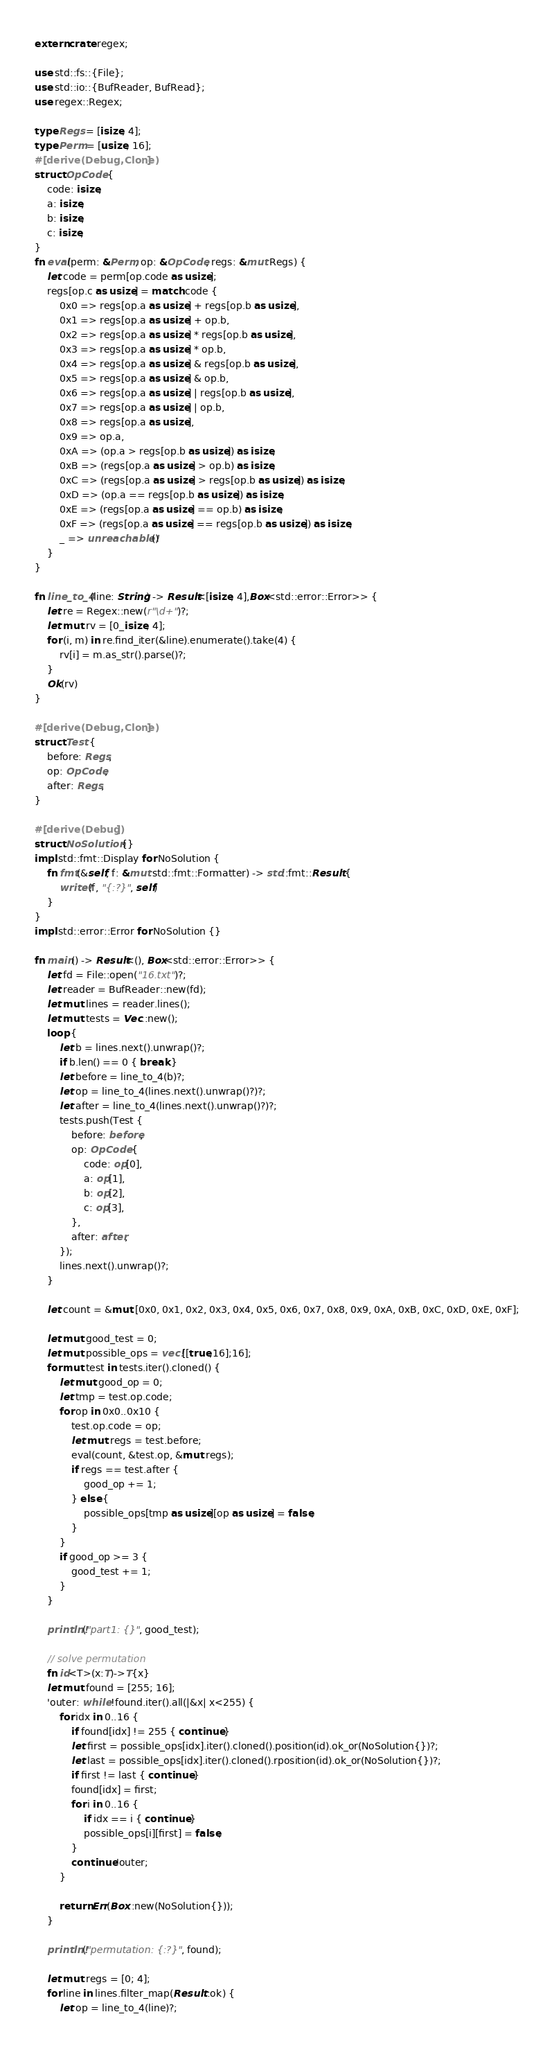Convert code to text. <code><loc_0><loc_0><loc_500><loc_500><_Rust_>extern crate regex;

use std::fs::{File};
use std::io::{BufReader, BufRead};
use regex::Regex;

type Regs = [isize; 4];
type Perm = [usize; 16];
#[derive(Debug,Clone)]
struct OpCode {
    code: isize,
    a: isize,
    b: isize,
    c: isize,
}
fn eval(perm: &Perm, op: &OpCode, regs: &mut Regs) {
    let code = perm[op.code as usize];
    regs[op.c as usize] = match code {
        0x0 => regs[op.a as usize] + regs[op.b as usize],
        0x1 => regs[op.a as usize] + op.b,
        0x2 => regs[op.a as usize] * regs[op.b as usize],
        0x3 => regs[op.a as usize] * op.b,
        0x4 => regs[op.a as usize] & regs[op.b as usize],
        0x5 => regs[op.a as usize] & op.b,
        0x6 => regs[op.a as usize] | regs[op.b as usize],
        0x7 => regs[op.a as usize] | op.b,
        0x8 => regs[op.a as usize],
        0x9 => op.a,
        0xA => (op.a > regs[op.b as usize]) as isize,
        0xB => (regs[op.a as usize] > op.b) as isize,
        0xC => (regs[op.a as usize] > regs[op.b as usize]) as isize,
        0xD => (op.a == regs[op.b as usize]) as isize,
        0xE => (regs[op.a as usize] == op.b) as isize,
        0xF => (regs[op.a as usize] == regs[op.b as usize]) as isize,
        _ => unreachable!()
    }
}

fn line_to_4(line: String) -> Result<[isize; 4],Box<std::error::Error>> {
    let re = Regex::new(r"\d+")?;
    let mut rv = [0_isize; 4];
    for (i, m) in re.find_iter(&line).enumerate().take(4) {
        rv[i] = m.as_str().parse()?;
    }
    Ok(rv)
}

#[derive(Debug,Clone)]
struct Test {
    before: Regs,
    op: OpCode,
    after: Regs,
}

#[derive(Debug)]
struct NoSolution {}
impl std::fmt::Display for NoSolution {
    fn fmt(&self, f: &mut std::fmt::Formatter) -> std::fmt::Result {
        write!(f, "{:?}", self)
    }
}
impl std::error::Error for NoSolution {}

fn main() -> Result<(), Box<std::error::Error>> {
    let fd = File::open("16.txt")?;
    let reader = BufReader::new(fd);
    let mut lines = reader.lines();
    let mut tests = Vec::new();
    loop {
        let b = lines.next().unwrap()?;
        if b.len() == 0 { break }
        let before = line_to_4(b)?;
        let op = line_to_4(lines.next().unwrap()?)?;
        let after = line_to_4(lines.next().unwrap()?)?;
        tests.push(Test {
            before: before,
            op: OpCode {
                code: op[0],
                a: op[1],
                b: op[2],
                c: op[3],
            },
            after: after,
        });
        lines.next().unwrap()?;
    }

    let count = &mut [0x0, 0x1, 0x2, 0x3, 0x4, 0x5, 0x6, 0x7, 0x8, 0x9, 0xA, 0xB, 0xC, 0xD, 0xE, 0xF];

    let mut good_test = 0;
    let mut possible_ops = vec![[true;16];16];
    for mut test in tests.iter().cloned() {
        let mut good_op = 0;
        let tmp = test.op.code;
        for op in 0x0..0x10 {
            test.op.code = op;
            let mut regs = test.before;
            eval(count, &test.op, &mut regs);
            if regs == test.after {
                good_op += 1;
            } else {
                possible_ops[tmp as usize][op as usize] = false;
            }
        }
        if good_op >= 3 {
            good_test += 1;
        }
    }

    println!("part1: {}", good_test);

    // solve permutation
    fn id<T>(x:T)->T{x}
    let mut found = [255; 16];
    'outer: while !found.iter().all(|&x| x<255) {
        for idx in 0..16 {
            if found[idx] != 255 { continue }
            let first = possible_ops[idx].iter().cloned().position(id).ok_or(NoSolution{})?;
            let last = possible_ops[idx].iter().cloned().rposition(id).ok_or(NoSolution{})?;
            if first != last { continue }
            found[idx] = first;
            for i in 0..16 {
                if idx == i { continue }
                possible_ops[i][first] = false;
            }
            continue 'outer;
        }

        return Err(Box::new(NoSolution{}));
    }

    println!("permutation: {:?}", found);

    let mut regs = [0; 4];
    for line in lines.filter_map(Result::ok) {
        let op = line_to_4(line)?;</code> 